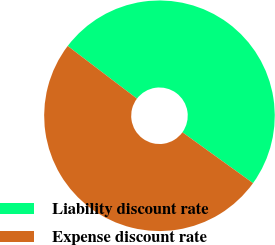<chart> <loc_0><loc_0><loc_500><loc_500><pie_chart><fcel>Liability discount rate<fcel>Expense discount rate<nl><fcel>49.59%<fcel>50.41%<nl></chart> 